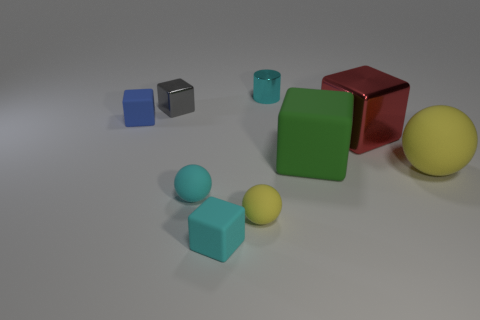Subtract all cyan blocks. How many blocks are left? 4 Subtract all small blue matte cubes. How many cubes are left? 4 Subtract all yellow cubes. Subtract all brown cylinders. How many cubes are left? 5 Add 1 small objects. How many objects exist? 10 Subtract all balls. How many objects are left? 6 Subtract 0 brown cubes. How many objects are left? 9 Subtract all gray shiny objects. Subtract all large matte blocks. How many objects are left? 7 Add 3 big things. How many big things are left? 6 Add 8 gray blocks. How many gray blocks exist? 9 